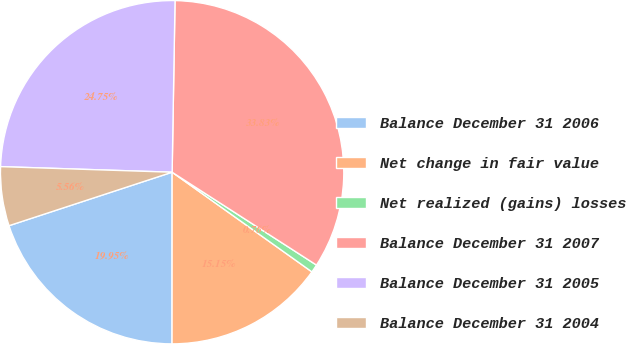Convert chart to OTSL. <chart><loc_0><loc_0><loc_500><loc_500><pie_chart><fcel>Balance December 31 2006<fcel>Net change in fair value<fcel>Net realized (gains) losses<fcel>Balance December 31 2007<fcel>Balance December 31 2005<fcel>Balance December 31 2004<nl><fcel>19.95%<fcel>15.15%<fcel>0.76%<fcel>33.83%<fcel>24.75%<fcel>5.56%<nl></chart> 